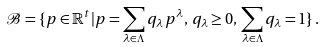Convert formula to latex. <formula><loc_0><loc_0><loc_500><loc_500>\mathcal { B } = \{ p \in \mathbb { R } ^ { t } | p = \sum _ { \lambda \in \Lambda } q _ { \lambda } \, p ^ { \lambda } , \, q _ { \lambda } \geq 0 , \, \sum _ { \lambda \in \Lambda } q _ { \lambda } = 1 \} \, .</formula> 